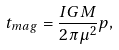<formula> <loc_0><loc_0><loc_500><loc_500>t _ { m a g } = \frac { I G M } { 2 \pi \mu ^ { 2 } } p ,</formula> 